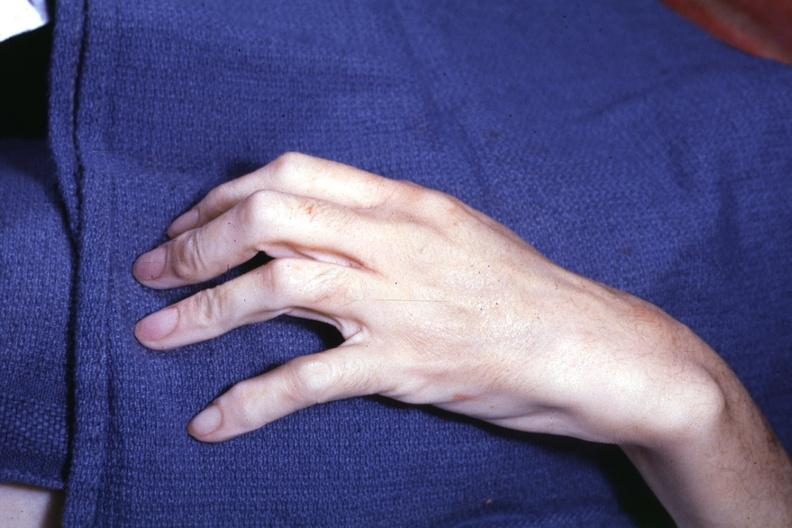does metastatic carcinoma oat cell see other slides?
Answer the question using a single word or phrase. No 